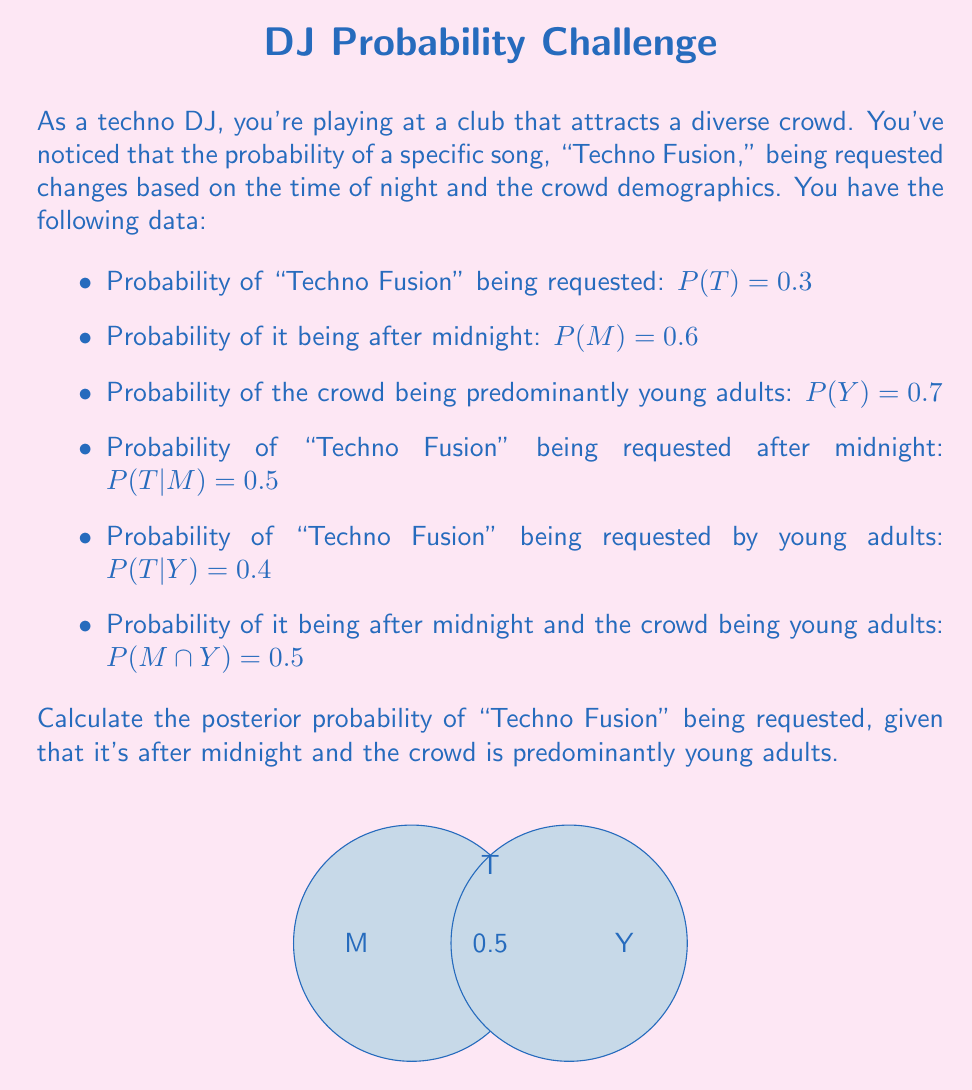Show me your answer to this math problem. To solve this problem, we'll use Bayes' theorem and the given probabilities. Let's break it down step by step:

1) We need to calculate $P(T|M \cap Y)$, which is the probability of "Techno Fusion" being requested given that it's after midnight and the crowd is young adults.

2) Bayes' theorem states:

   $$P(T|M \cap Y) = \frac{P(M \cap Y|T) \cdot P(T)}{P(M \cap Y)}$$

3) We know $P(T) = 0.3$ and $P(M \cap Y) = 0.5$, but we need to calculate $P(M \cap Y|T)$.

4) Using the chain rule of probability:

   $$P(M \cap Y|T) = P(M|T) \cdot P(Y|T)$$

5) We can calculate $P(M|T)$ using Bayes' theorem:

   $$P(M|T) = \frac{P(T|M) \cdot P(M)}{P(T)} = \frac{0.5 \cdot 0.6}{0.3} = 1$$

6) Similarly for $P(Y|T)$:

   $$P(Y|T) = \frac{P(T|Y) \cdot P(Y)}{P(T)} = \frac{0.4 \cdot 0.7}{0.3} = \frac{28}{30}$$

7) Now we can calculate $P(M \cap Y|T)$:

   $$P(M \cap Y|T) = 1 \cdot \frac{28}{30} = \frac{28}{30}$$

8) Plugging everything into Bayes' theorem:

   $$P(T|M \cap Y) = \frac{\frac{28}{30} \cdot 0.3}{0.5} = \frac{28}{50} = 0.56$$

Therefore, the posterior probability of "Techno Fusion" being requested, given that it's after midnight and the crowd is predominantly young adults, is 0.56 or 56%.
Answer: 0.56 